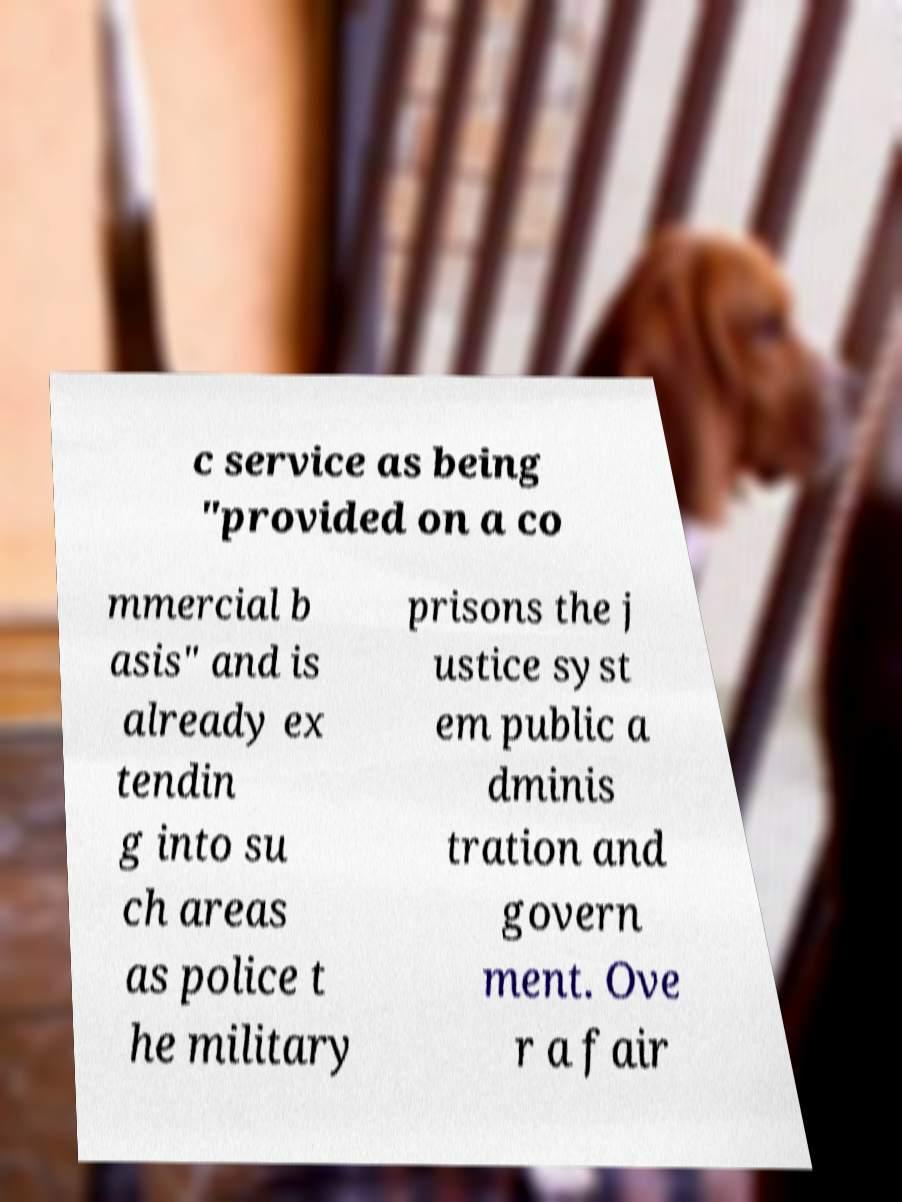Could you extract and type out the text from this image? c service as being "provided on a co mmercial b asis" and is already ex tendin g into su ch areas as police t he military prisons the j ustice syst em public a dminis tration and govern ment. Ove r a fair 